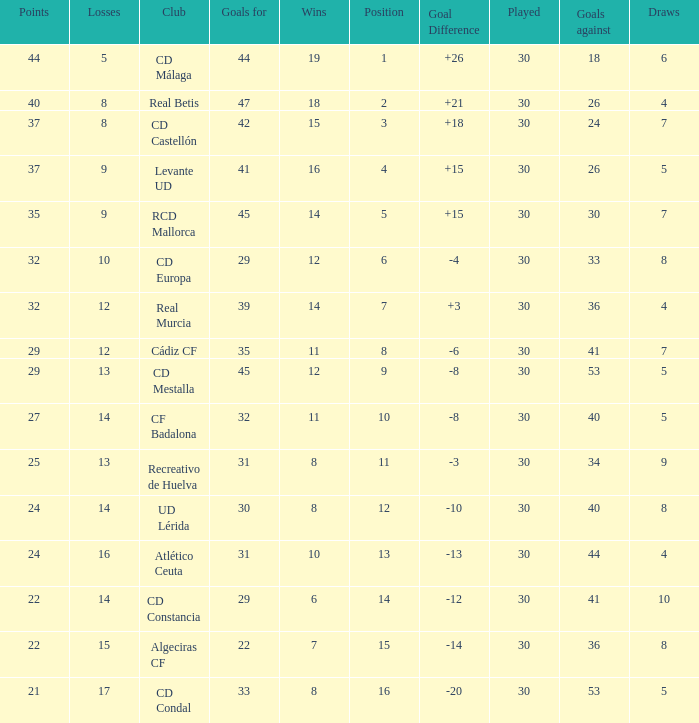What is the losses when the goal difference is larger than 26? None. 